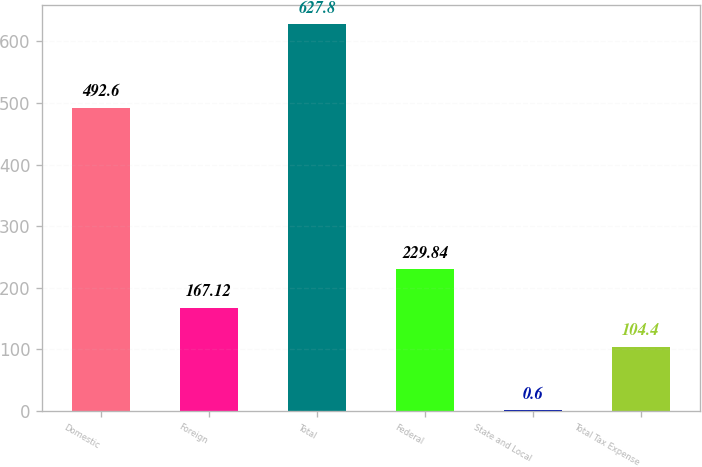Convert chart. <chart><loc_0><loc_0><loc_500><loc_500><bar_chart><fcel>Domestic<fcel>Foreign<fcel>Total<fcel>Federal<fcel>State and Local<fcel>Total Tax Expense<nl><fcel>492.6<fcel>167.12<fcel>627.8<fcel>229.84<fcel>0.6<fcel>104.4<nl></chart> 